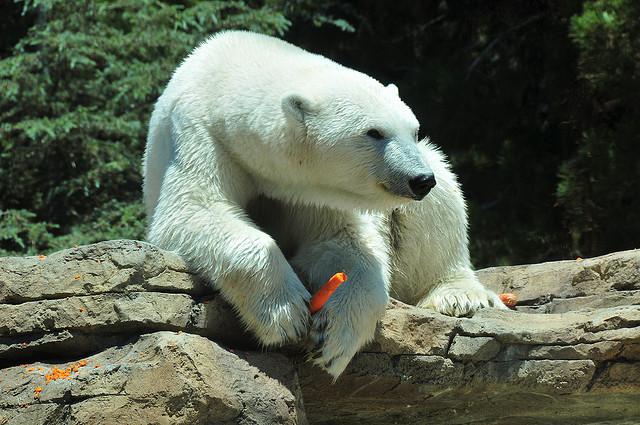What color is this bear?
Give a very brief answer. White. What is the polar bear holding?
Concise answer only. Carrot. Is the polar bear hibernating?
Answer briefly. No. How many bears are there?
Keep it brief. 1. 